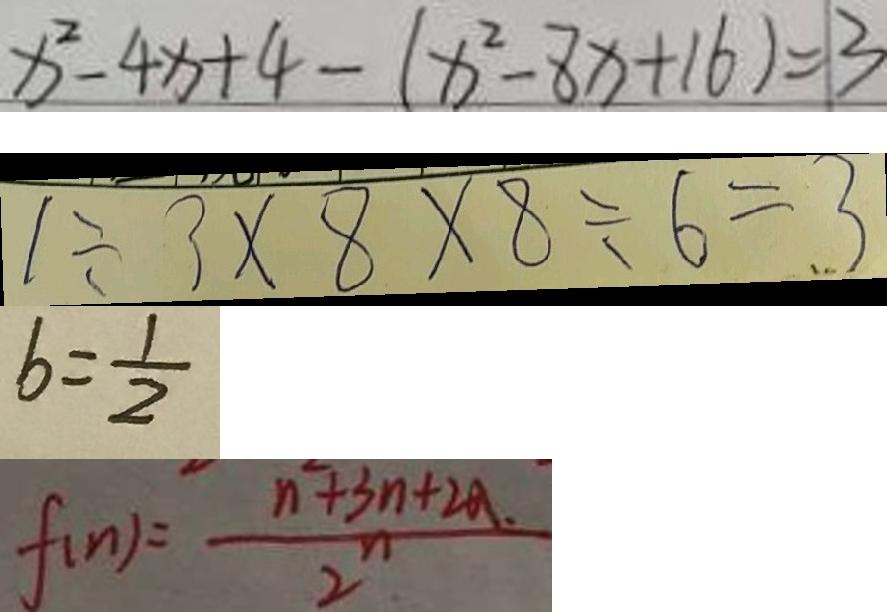<formula> <loc_0><loc_0><loc_500><loc_500>x ^ { 2 } - 4 x + 4 - ( x ^ { 2 } - 8 x + 1 6 ) = 1 3 
 1 \div 3 \times 8 \times 8 \div 6 = 3 
 b = \frac { 1 } { 2 } 
 f ( n ) = \frac { n ^ { 2 } + 3 n + 2 a . } { 2 ^ { n } }</formula> 